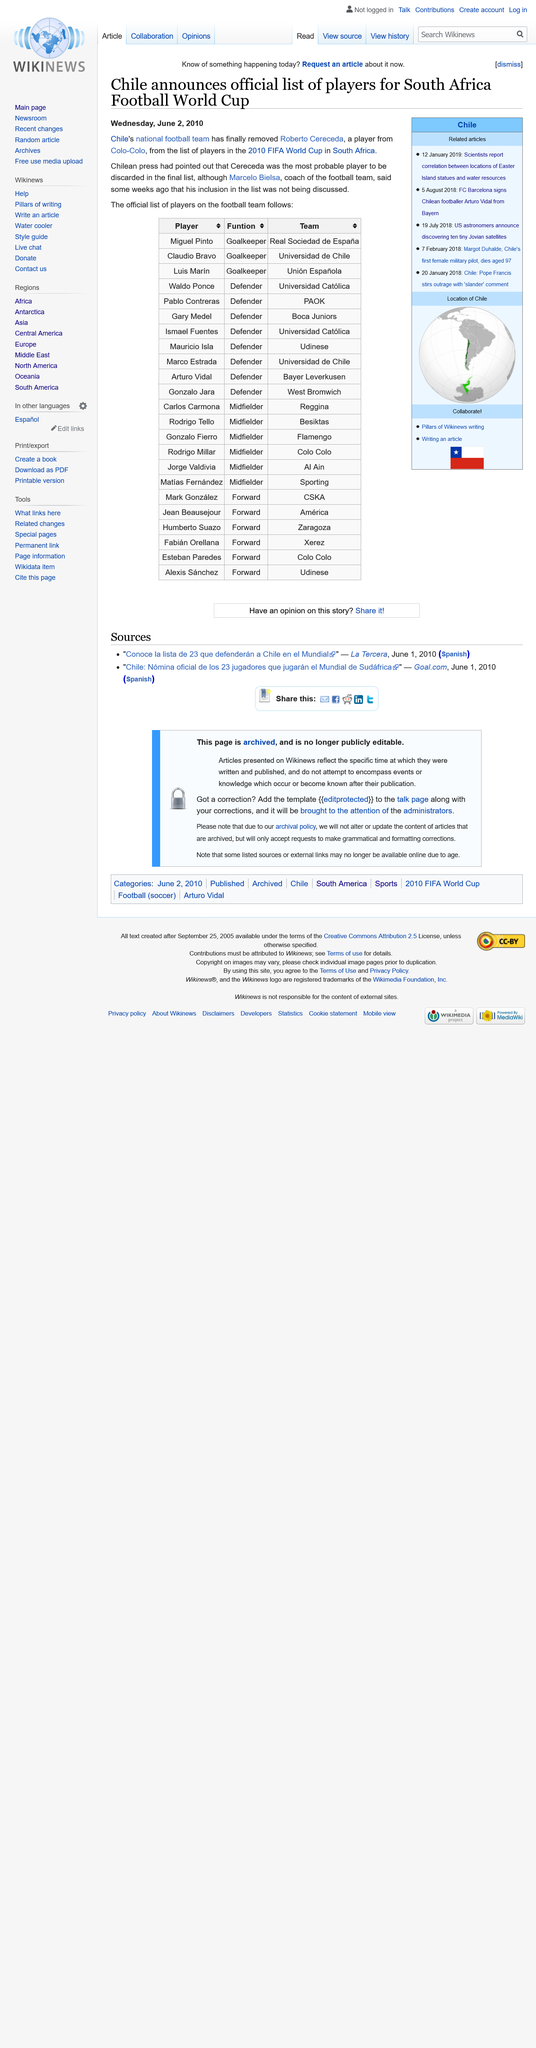Specify some key components in this picture. The official list of players for the Chilean squad at the 2010 FIFA World Cup was announced on Wednesday, June 2, 2010. Marcelo Bielsa coached the Chile national football team at the 2010 World Cup held in South Africa. The player Roberto Cereceda, who played for Colo-Colo, has been removed from the list of players who will officially form the squad. 